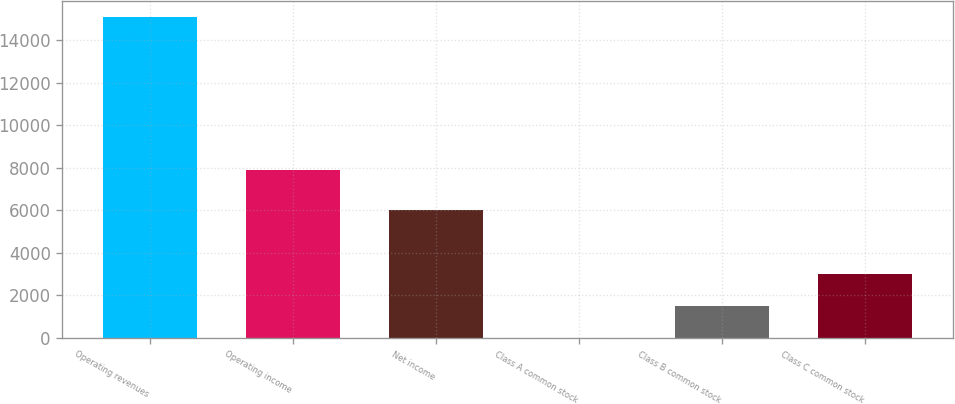Convert chart. <chart><loc_0><loc_0><loc_500><loc_500><bar_chart><fcel>Operating revenues<fcel>Operating income<fcel>Net income<fcel>Class A common stock<fcel>Class B common stock<fcel>Class C common stock<nl><fcel>15082<fcel>7883<fcel>5991<fcel>2.49<fcel>1510.44<fcel>3018.39<nl></chart> 